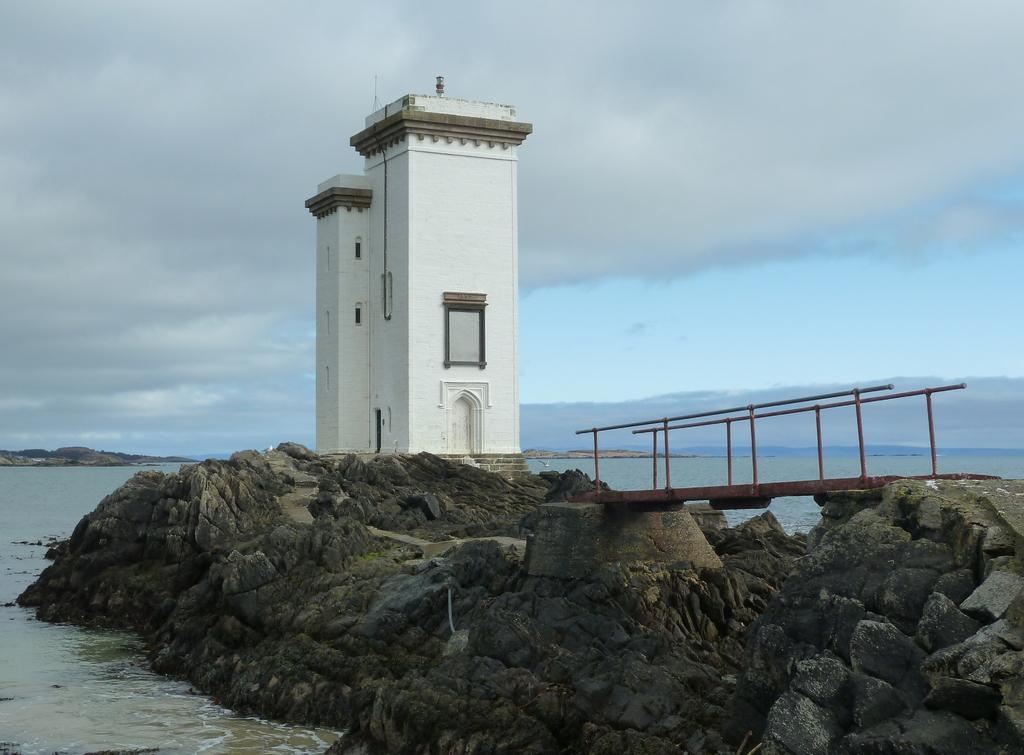In one or two sentences, can you explain what this image depicts? In the center of the image we can see a building with windows and door. To the right side, we can see a bridge with metal railing, a group of rocks and in the background, we can see the water and the cloudy sky. 